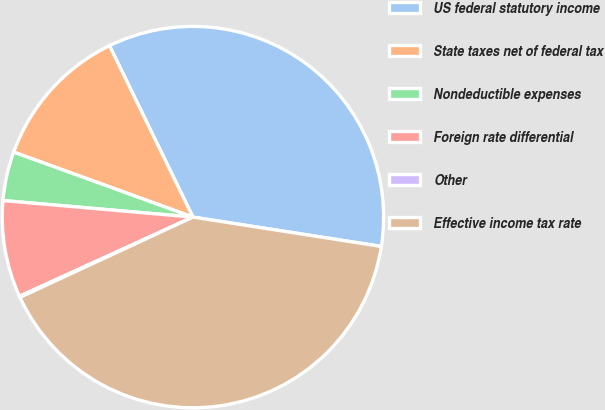<chart> <loc_0><loc_0><loc_500><loc_500><pie_chart><fcel>US federal statutory income<fcel>State taxes net of federal tax<fcel>Nondeductible expenses<fcel>Foreign rate differential<fcel>Other<fcel>Effective income tax rate<nl><fcel>34.67%<fcel>12.25%<fcel>4.15%<fcel>8.2%<fcel>0.1%<fcel>40.62%<nl></chart> 